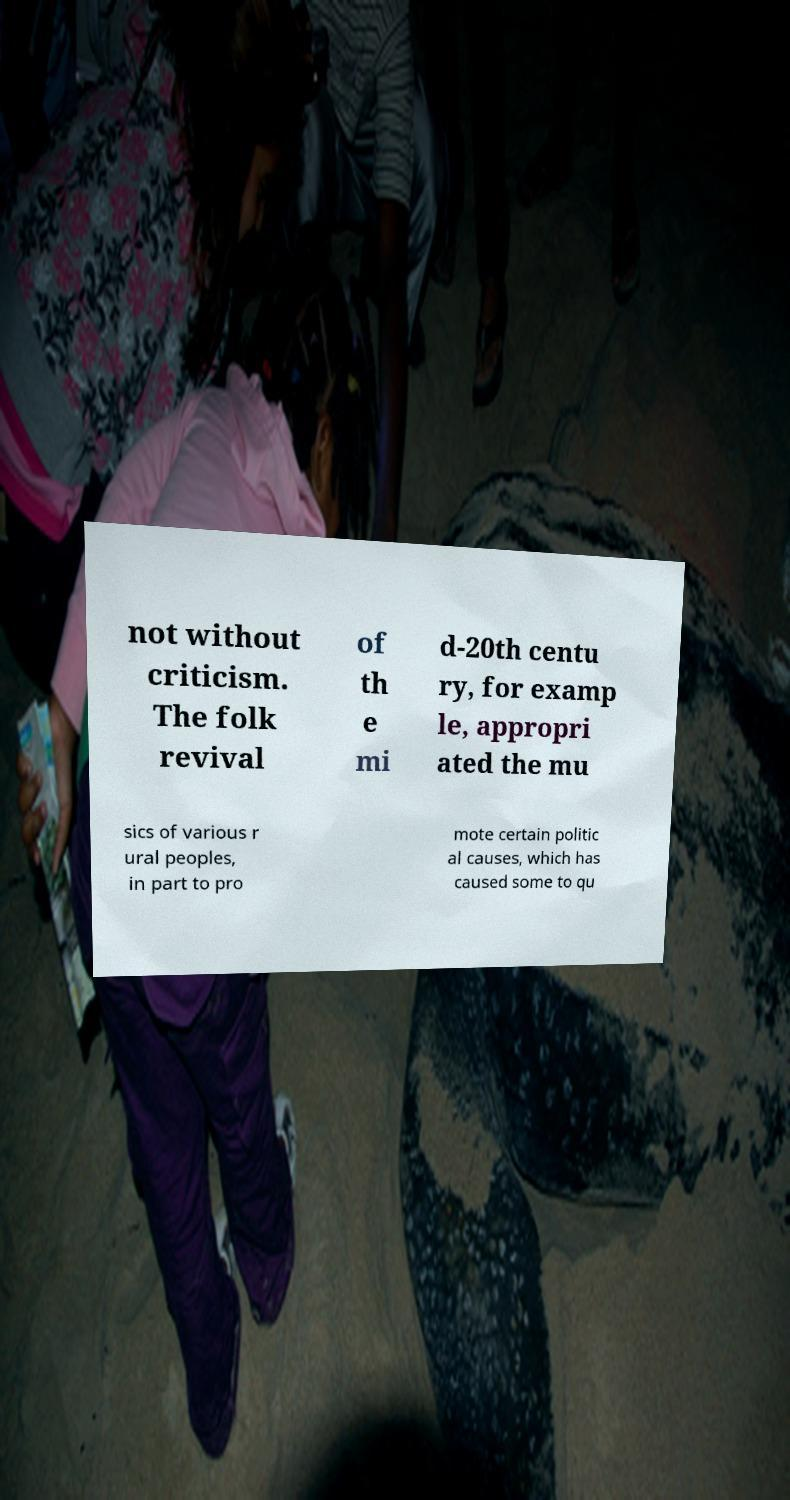I need the written content from this picture converted into text. Can you do that? not without criticism. The folk revival of th e mi d-20th centu ry, for examp le, appropri ated the mu sics of various r ural peoples, in part to pro mote certain politic al causes, which has caused some to qu 